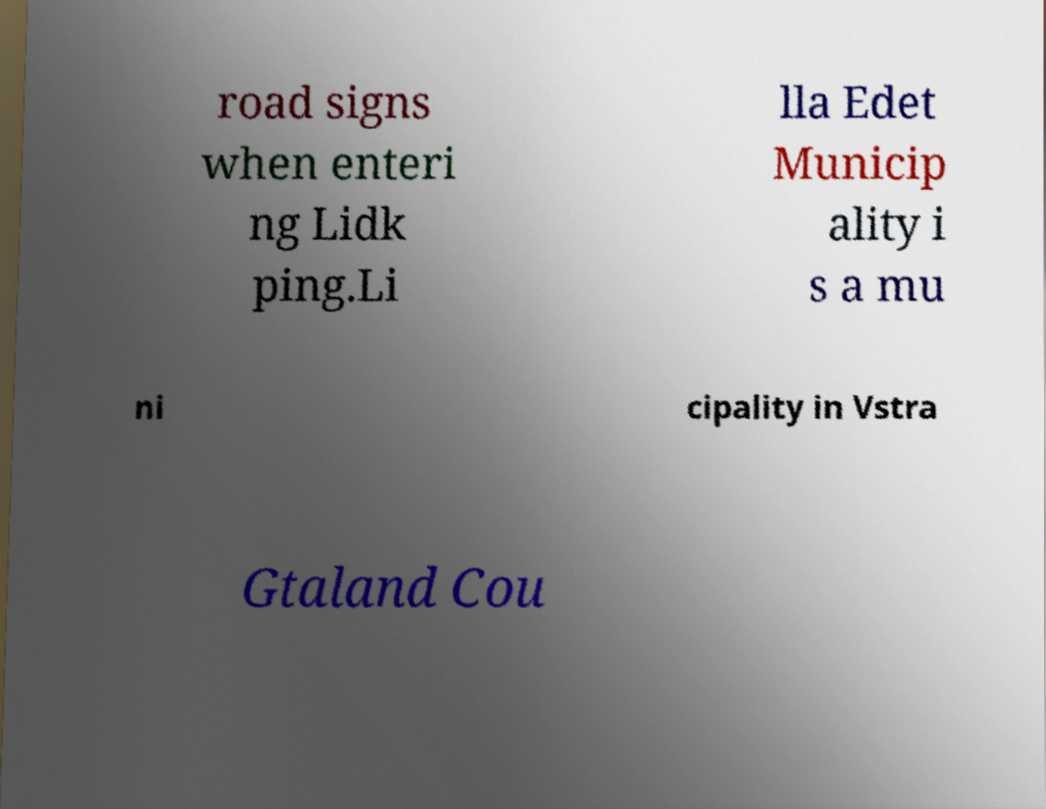For documentation purposes, I need the text within this image transcribed. Could you provide that? road signs when enteri ng Lidk ping.Li lla Edet Municip ality i s a mu ni cipality in Vstra Gtaland Cou 